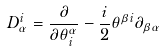<formula> <loc_0><loc_0><loc_500><loc_500>D _ { \alpha } ^ { i } = { \frac { \partial } { \partial \theta _ { i } ^ { \alpha } } } - { \frac { i } { 2 } } \theta ^ { \beta i } \partial _ { \beta \alpha }</formula> 